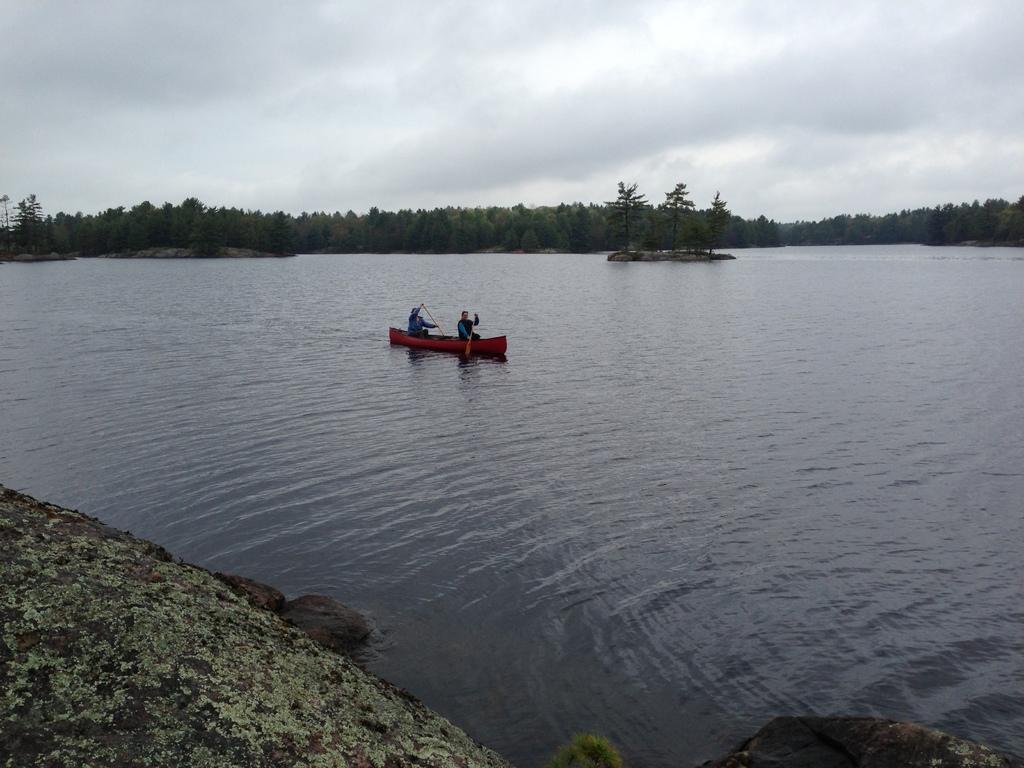In one or two sentences, can you explain what this image depicts? In this image I can see a boat and two people are sitting in the boat and holding paddles. The boat is on the water. I can see few trees and few stones. The sky is in white and blue color. 